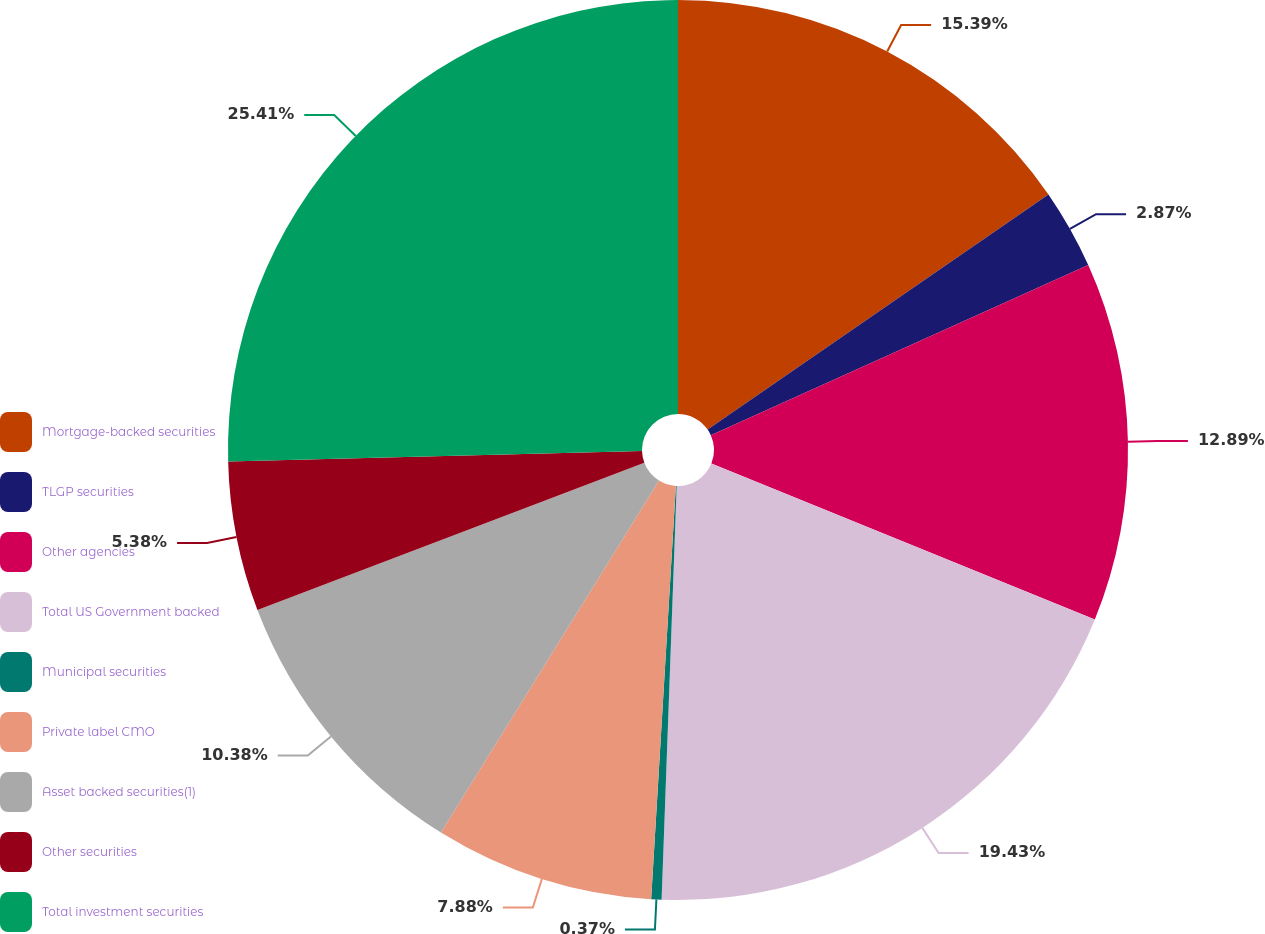<chart> <loc_0><loc_0><loc_500><loc_500><pie_chart><fcel>Mortgage-backed securities<fcel>TLGP securities<fcel>Other agencies<fcel>Total US Government backed<fcel>Municipal securities<fcel>Private label CMO<fcel>Asset backed securities(1)<fcel>Other securities<fcel>Total investment securities<nl><fcel>15.39%<fcel>2.87%<fcel>12.89%<fcel>19.43%<fcel>0.37%<fcel>7.88%<fcel>10.38%<fcel>5.38%<fcel>25.41%<nl></chart> 